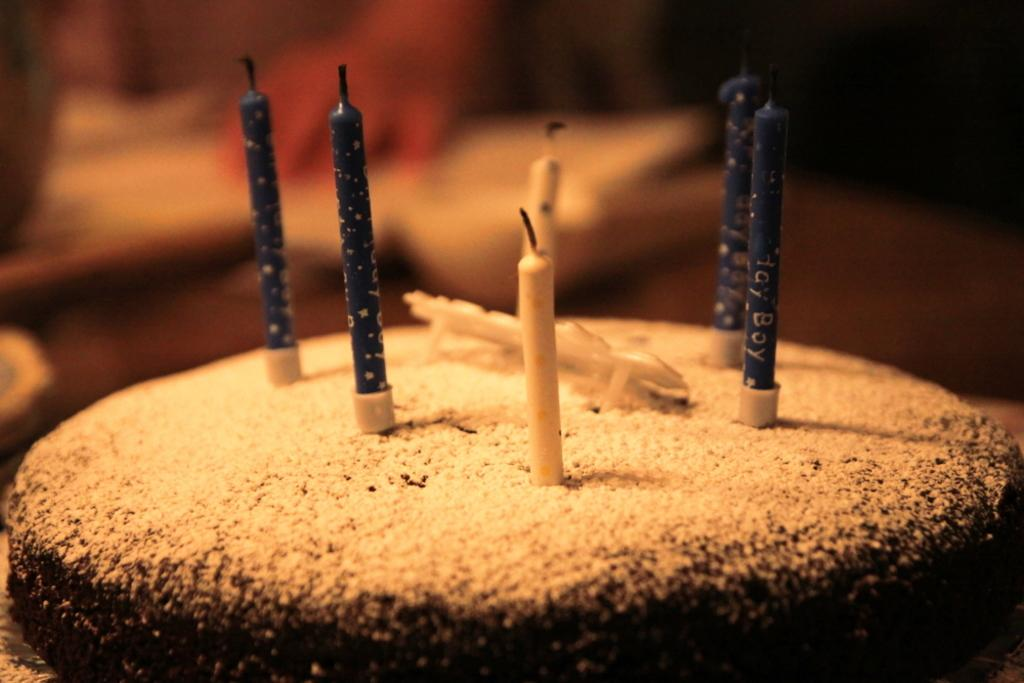What is on top of the cake in the image? There are candles on the cake in the image. Can you describe the background of the image? The background of the image is blurred. What is the value of the silver operation in the image? There is no silver operation or value mentioned in the image; it only features a cake with candles and a blurred background. 